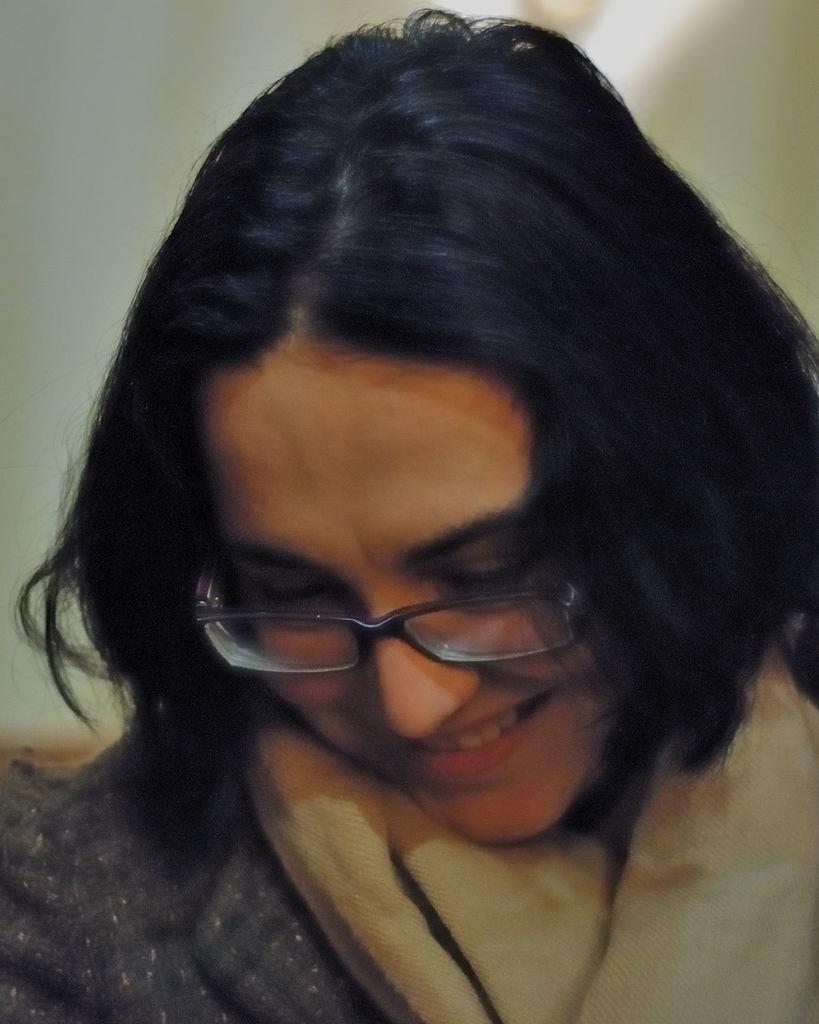How would you summarize this image in a sentence or two? In the foreground of this image, there is a woman wearing a grey jacket and a scarf around her neck and having smile on her face and the background image is blurred. 